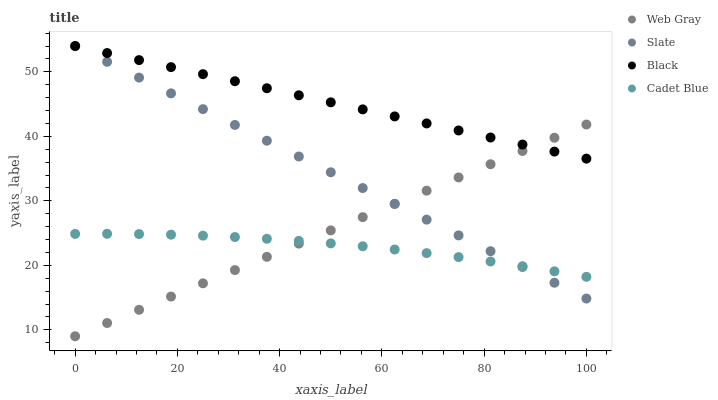Does Cadet Blue have the minimum area under the curve?
Answer yes or no. Yes. Does Black have the maximum area under the curve?
Answer yes or no. Yes. Does Slate have the minimum area under the curve?
Answer yes or no. No. Does Slate have the maximum area under the curve?
Answer yes or no. No. Is Slate the smoothest?
Answer yes or no. Yes. Is Cadet Blue the roughest?
Answer yes or no. Yes. Is Web Gray the smoothest?
Answer yes or no. No. Is Web Gray the roughest?
Answer yes or no. No. Does Web Gray have the lowest value?
Answer yes or no. Yes. Does Slate have the lowest value?
Answer yes or no. No. Does Black have the highest value?
Answer yes or no. Yes. Does Web Gray have the highest value?
Answer yes or no. No. Is Cadet Blue less than Black?
Answer yes or no. Yes. Is Black greater than Cadet Blue?
Answer yes or no. Yes. Does Slate intersect Web Gray?
Answer yes or no. Yes. Is Slate less than Web Gray?
Answer yes or no. No. Is Slate greater than Web Gray?
Answer yes or no. No. Does Cadet Blue intersect Black?
Answer yes or no. No. 